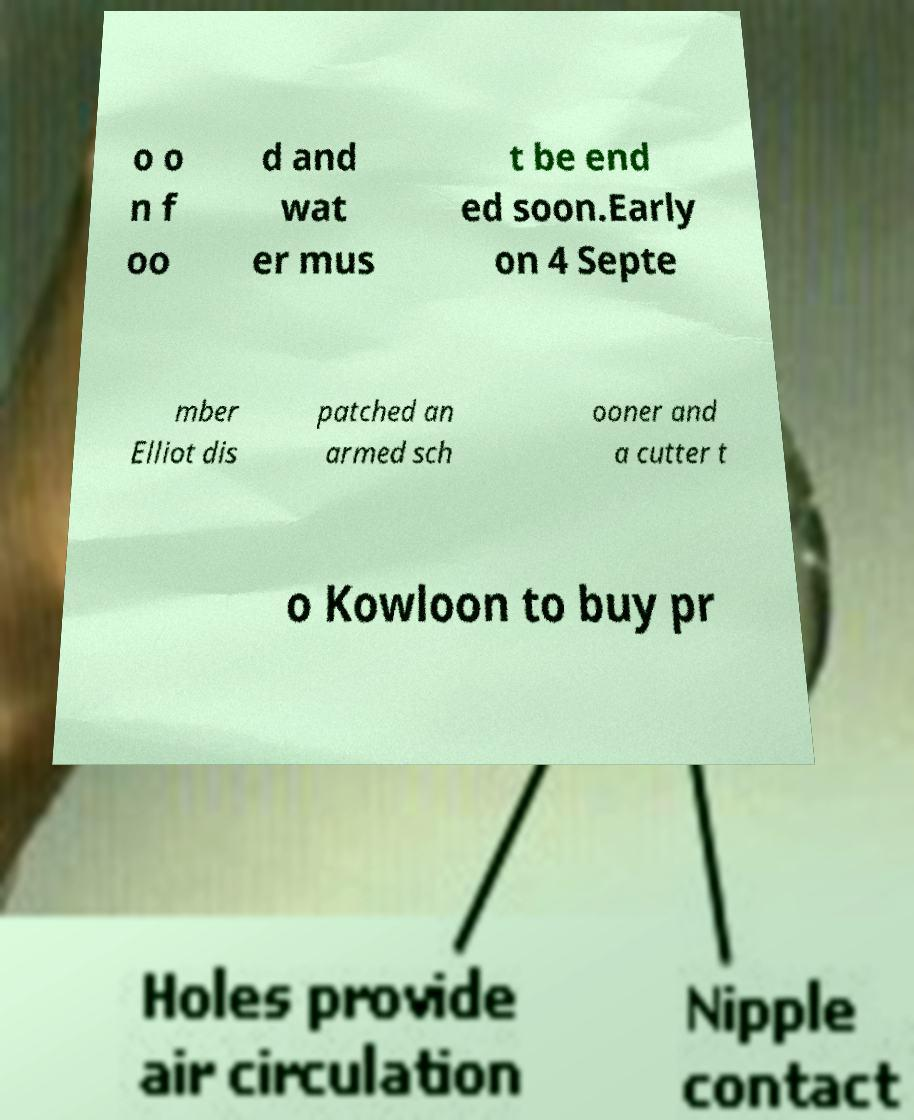Can you read and provide the text displayed in the image?This photo seems to have some interesting text. Can you extract and type it out for me? o o n f oo d and wat er mus t be end ed soon.Early on 4 Septe mber Elliot dis patched an armed sch ooner and a cutter t o Kowloon to buy pr 